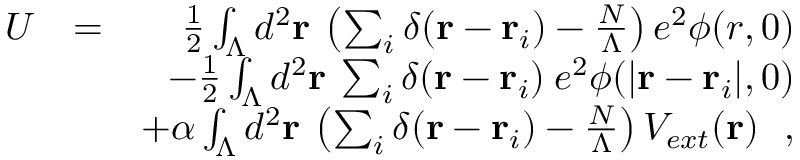Convert formula to latex. <formula><loc_0><loc_0><loc_500><loc_500>\begin{array} { r l r } { U } & { = } & { \frac { 1 } { 2 } \int _ { \Lambda } d ^ { 2 } { r } \, \left ( \sum _ { i } \delta ( { r } - { r } _ { i } ) - \frac { N } { \Lambda } \right ) e ^ { 2 } \phi ( r , 0 ) } \\ & { \mathrm - \frac { 1 } { 2 } \int _ { \Lambda } d ^ { 2 } { r } \, \sum _ { i } \delta ( { r } - { r } _ { i } ) \, e ^ { 2 } \phi ( | { r } - { r } _ { i } | , 0 ) } \\ & { \mathrm + \alpha \int _ { \Lambda } d ^ { 2 } { r } \, \left ( \sum _ { i } \delta ( { r } - { r } _ { i } ) - \frac { N } { \Lambda } \right ) V _ { e x t } ( { r } ) , } \end{array}</formula> 